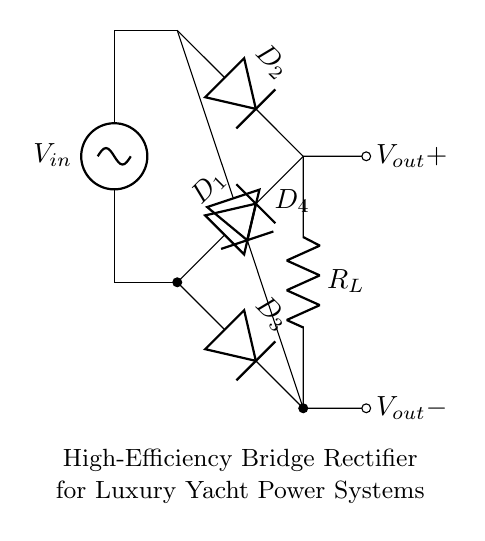What type of circuit is shown? The circuit is a bridge rectifier, which is identified by the arrangement of four diodes in a bridge configuration. This configuration allows both halves of the input AC waveform to be converted into DC voltage.
Answer: Bridge rectifier How many diodes are in the circuit? There are four diodes in the circuit, labeled as D1, D2, D3, and D4. Each diode serves to conduct current during specific half cycles of the voltage input to produce a unidirectional flow.
Answer: Four What is the purpose of the resistor labeled R_L? The resistor R_L acts as the load in the circuit; it is where the rectified output voltage is applied. It represents the component that will use the power converted from AC to DC.
Answer: Load What does the input voltage source represent? The input voltage source represents the alternating current (AC) power supply which is converted to direct current (DC) by the bridge rectifier. The voltage source provides the necessary electrical energy for this process.
Answer: AC power supply During which half cycle do diodes D1 and D2 conduct? D1 and D2 conduct during the positive half cycle of the input voltage, allowing current to flow through the load. This behavior is a characteristic of the bridge rectifier, as it utilizes both positive and negative halves of the AC input.
Answer: Positive half cycle What is the output voltage polarity for this rectifier? The output voltage polarity is positive at the output terminal labeled V_out+ and negative at V_out-. This indicates that the output is a unidirectional voltage after rectification.
Answer: Positive and negative 